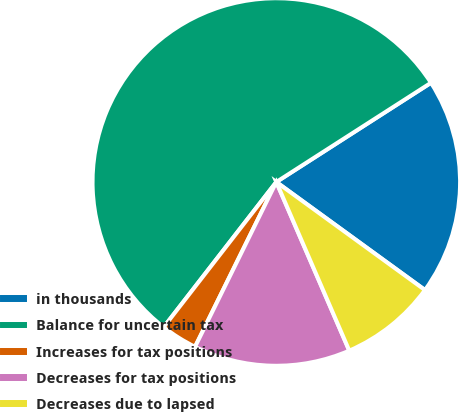Convert chart to OTSL. <chart><loc_0><loc_0><loc_500><loc_500><pie_chart><fcel>in thousands<fcel>Balance for uncertain tax<fcel>Increases for tax positions<fcel>Decreases for tax positions<fcel>Decreases due to lapsed<nl><fcel>19.08%<fcel>55.42%<fcel>3.21%<fcel>13.79%<fcel>8.5%<nl></chart> 